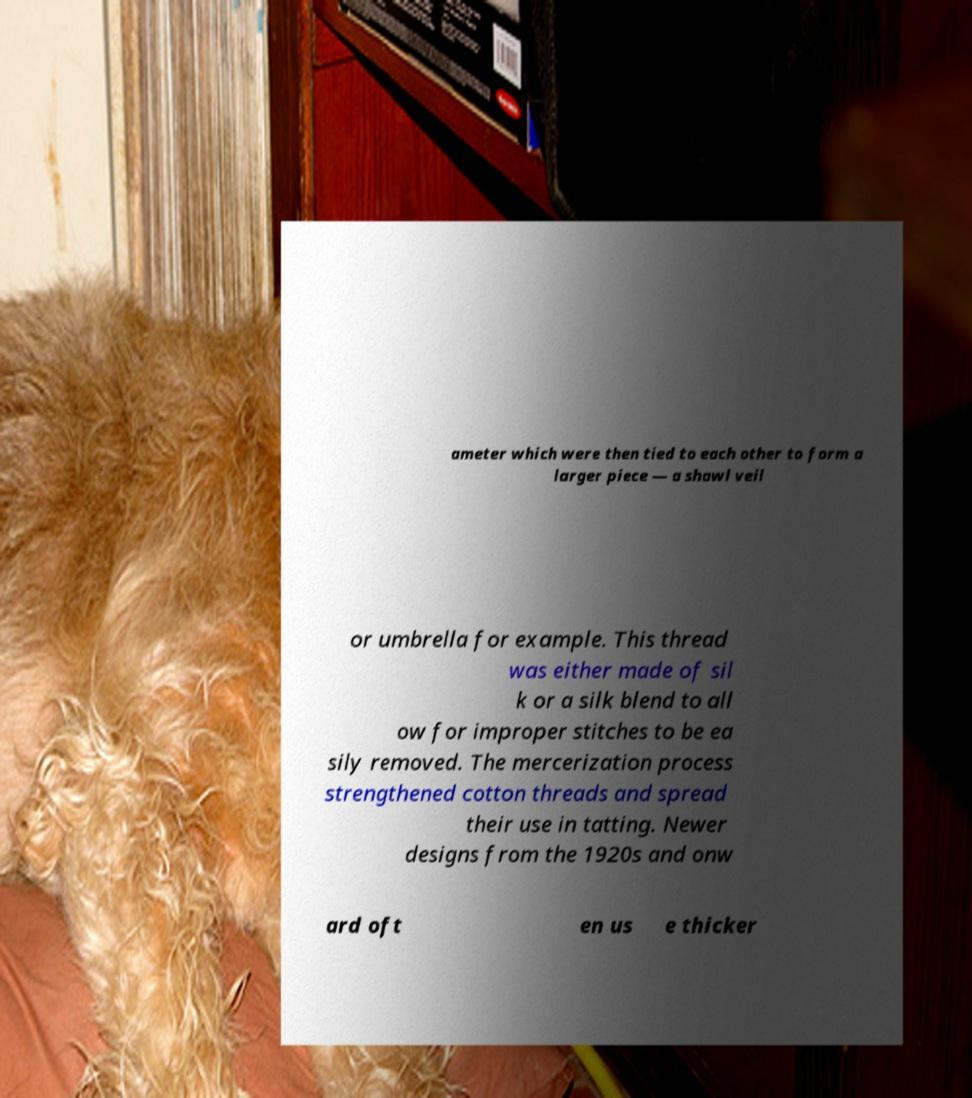Please read and relay the text visible in this image. What does it say? ameter which were then tied to each other to form a larger piece — a shawl veil or umbrella for example. This thread was either made of sil k or a silk blend to all ow for improper stitches to be ea sily removed. The mercerization process strengthened cotton threads and spread their use in tatting. Newer designs from the 1920s and onw ard oft en us e thicker 